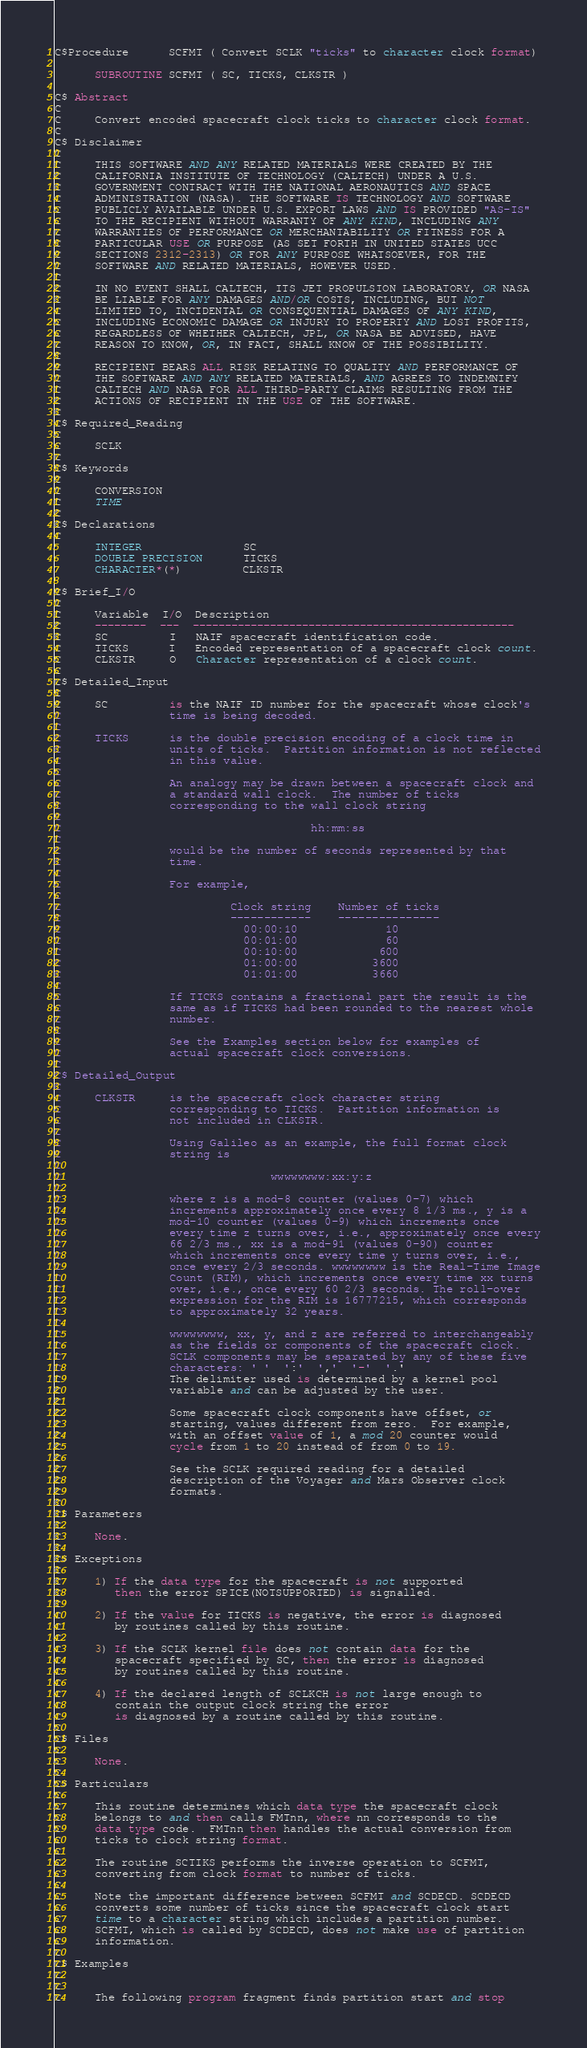Convert code to text. <code><loc_0><loc_0><loc_500><loc_500><_FORTRAN_>C$Procedure      SCFMT ( Convert SCLK "ticks" to character clock format)
 
      SUBROUTINE SCFMT ( SC, TICKS, CLKSTR )
 
C$ Abstract
C
C     Convert encoded spacecraft clock ticks to character clock format.
C
C$ Disclaimer
C
C     THIS SOFTWARE AND ANY RELATED MATERIALS WERE CREATED BY THE
C     CALIFORNIA INSTITUTE OF TECHNOLOGY (CALTECH) UNDER A U.S.
C     GOVERNMENT CONTRACT WITH THE NATIONAL AERONAUTICS AND SPACE
C     ADMINISTRATION (NASA). THE SOFTWARE IS TECHNOLOGY AND SOFTWARE
C     PUBLICLY AVAILABLE UNDER U.S. EXPORT LAWS AND IS PROVIDED "AS-IS"
C     TO THE RECIPIENT WITHOUT WARRANTY OF ANY KIND, INCLUDING ANY
C     WARRANTIES OF PERFORMANCE OR MERCHANTABILITY OR FITNESS FOR A
C     PARTICULAR USE OR PURPOSE (AS SET FORTH IN UNITED STATES UCC
C     SECTIONS 2312-2313) OR FOR ANY PURPOSE WHATSOEVER, FOR THE
C     SOFTWARE AND RELATED MATERIALS, HOWEVER USED.
C
C     IN NO EVENT SHALL CALTECH, ITS JET PROPULSION LABORATORY, OR NASA
C     BE LIABLE FOR ANY DAMAGES AND/OR COSTS, INCLUDING, BUT NOT
C     LIMITED TO, INCIDENTAL OR CONSEQUENTIAL DAMAGES OF ANY KIND,
C     INCLUDING ECONOMIC DAMAGE OR INJURY TO PROPERTY AND LOST PROFITS,
C     REGARDLESS OF WHETHER CALTECH, JPL, OR NASA BE ADVISED, HAVE
C     REASON TO KNOW, OR, IN FACT, SHALL KNOW OF THE POSSIBILITY.
C
C     RECIPIENT BEARS ALL RISK RELATING TO QUALITY AND PERFORMANCE OF
C     THE SOFTWARE AND ANY RELATED MATERIALS, AND AGREES TO INDEMNIFY
C     CALTECH AND NASA FOR ALL THIRD-PARTY CLAIMS RESULTING FROM THE
C     ACTIONS OF RECIPIENT IN THE USE OF THE SOFTWARE.
C
C$ Required_Reading
C
C     SCLK
C
C$ Keywords
C
C     CONVERSION
C     TIME
C
C$ Declarations
C
      INTEGER               SC
      DOUBLE PRECISION      TICKS
      CHARACTER*(*)         CLKSTR
 
C$ Brief_I/O
C
C     Variable  I/O  Description
C     --------  ---  --------------------------------------------------
C     SC         I   NAIF spacecraft identification code.
C     TICKS      I   Encoded representation of a spacecraft clock count.
C     CLKSTR     O   Character representation of a clock count.
C
C$ Detailed_Input
C
C     SC         is the NAIF ID number for the spacecraft whose clock's
C                time is being decoded.
C
C     TICKS      is the double precision encoding of a clock time in
C                units of ticks.  Partition information is not reflected
C                in this value.
C
C                An analogy may be drawn between a spacecraft clock and
C                a standard wall clock.  The number of ticks
C                corresponding to the wall clock string
C
C                                     hh:mm:ss
C
C                would be the number of seconds represented by that
C                time.
C
C                For example,
C
C                         Clock string    Number of ticks
C                         ------------    ---------------
C                           00:00:10             10
C                           00:01:00             60
C                           00:10:00            600
C                           01:00:00           3600
C                           01:01:00           3660
C
C                If TICKS contains a fractional part the result is the
C                same as if TICKS had been rounded to the nearest whole
C                number.
C
C                See the Examples section below for examples of
C                actual spacecraft clock conversions.
C
C$ Detailed_Output
C
C     CLKSTR     is the spacecraft clock character string
C                corresponding to TICKS.  Partition information is
C                not included in CLKSTR.
C
C                Using Galileo as an example, the full format clock
C                string is
C
C                               wwwwwwww:xx:y:z
C
C                where z is a mod-8 counter (values 0-7) which
C                increments approximately once every 8 1/3 ms., y is a
C                mod-10 counter (values 0-9) which increments once
C                every time z turns over, i.e., approximately once every
C                66 2/3 ms., xx is a mod-91 (values 0-90) counter
C                which increments once every time y turns over, i.e.,
C                once every 2/3 seconds. wwwwwwww is the Real-Time Image
C                Count (RIM), which increments once every time xx turns
C                over, i.e., once every 60 2/3 seconds. The roll-over
C                expression for the RIM is 16777215, which corresponds
C                to approximately 32 years.
C
C                wwwwwwww, xx, y, and z are referred to interchangeably
C                as the fields or components of the spacecraft clock.
C                SCLK components may be separated by any of these five
C                characters: ' '  ':'  ','  '-'  '.'
C                The delimiter used is determined by a kernel pool
C                variable and can be adjusted by the user.
C
C                Some spacecraft clock components have offset, or
C                starting, values different from zero.  For example,
C                with an offset value of 1, a mod 20 counter would
C                cycle from 1 to 20 instead of from 0 to 19.
C
C                See the SCLK required reading for a detailed
C                description of the Voyager and Mars Observer clock
C                formats.
C
C$ Parameters
C
C     None.
C
C$ Exceptions
C
C     1) If the data type for the spacecraft is not supported
C        then the error SPICE(NOTSUPPORTED) is signalled.
C
C     2) If the value for TICKS is negative, the error is diagnosed
C        by routines called by this routine.
C
C     3) If the SCLK kernel file does not contain data for the
C        spacecraft specified by SC, then the error is diagnosed
C        by routines called by this routine.
C
C     4) If the declared length of SCLKCH is not large enough to
C        contain the output clock string the error
C        is diagnosed by a routine called by this routine.
C
C$ Files
C
C     None.
C
C$ Particulars
C
C     This routine determines which data type the spacecraft clock
C     belongs to and then calls FMTnn, where nn corresponds to the
C     data type code.  FMTnn then handles the actual conversion from
C     ticks to clock string format.
C
C     The routine SCTIKS performs the inverse operation to SCFMT,
C     converting from clock format to number of ticks.
C
C     Note the important difference between SCFMT and SCDECD. SCDECD
C     converts some number of ticks since the spacecraft clock start
C     time to a character string which includes a partition number.
C     SCFMT, which is called by SCDECD, does not make use of partition
C     information.
C
C$ Examples
C
C
C     The following program fragment finds partition start and stop</code> 